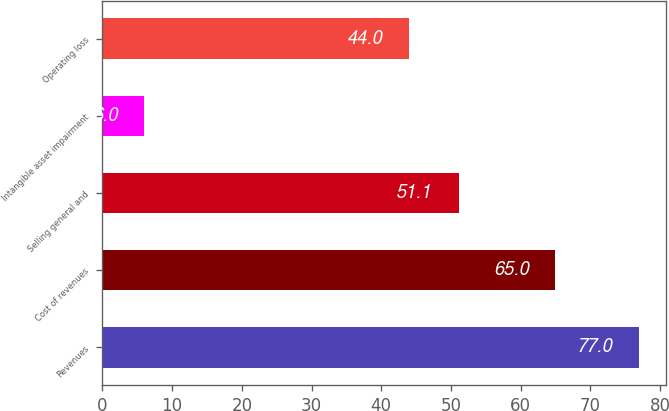<chart> <loc_0><loc_0><loc_500><loc_500><bar_chart><fcel>Revenues<fcel>Cost of revenues<fcel>Selling general and<fcel>Intangible asset impairment<fcel>Operating loss<nl><fcel>77<fcel>65<fcel>51.1<fcel>6<fcel>44<nl></chart> 